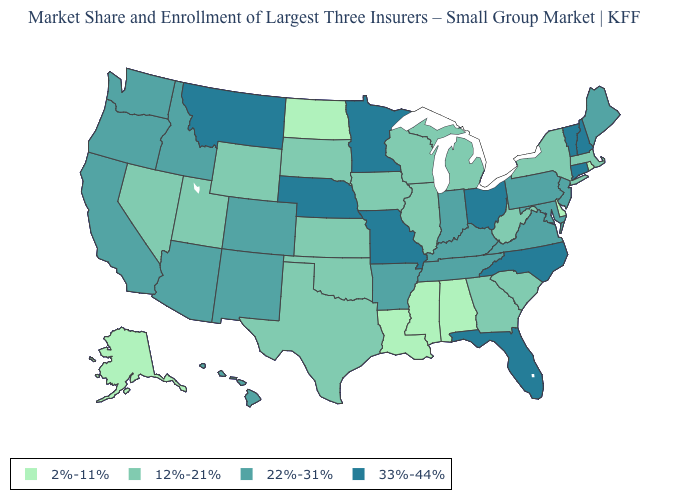Does the map have missing data?
Short answer required. No. What is the highest value in the USA?
Answer briefly. 33%-44%. What is the value of New York?
Concise answer only. 12%-21%. What is the value of Ohio?
Be succinct. 33%-44%. Name the states that have a value in the range 2%-11%?
Quick response, please. Alabama, Alaska, Delaware, Louisiana, Mississippi, North Dakota, Rhode Island. Name the states that have a value in the range 33%-44%?
Write a very short answer. Connecticut, Florida, Minnesota, Missouri, Montana, Nebraska, New Hampshire, North Carolina, Ohio, Vermont. What is the value of Iowa?
Keep it brief. 12%-21%. Does Alaska have the lowest value in the West?
Write a very short answer. Yes. How many symbols are there in the legend?
Write a very short answer. 4. Which states have the lowest value in the USA?
Be succinct. Alabama, Alaska, Delaware, Louisiana, Mississippi, North Dakota, Rhode Island. Name the states that have a value in the range 22%-31%?
Short answer required. Arizona, Arkansas, California, Colorado, Hawaii, Idaho, Indiana, Kentucky, Maine, Maryland, New Jersey, New Mexico, Oregon, Pennsylvania, Tennessee, Virginia, Washington. Among the states that border Oregon , which have the lowest value?
Keep it brief. Nevada. Does Missouri have the highest value in the USA?
Quick response, please. Yes. What is the value of New York?
Give a very brief answer. 12%-21%. How many symbols are there in the legend?
Write a very short answer. 4. 